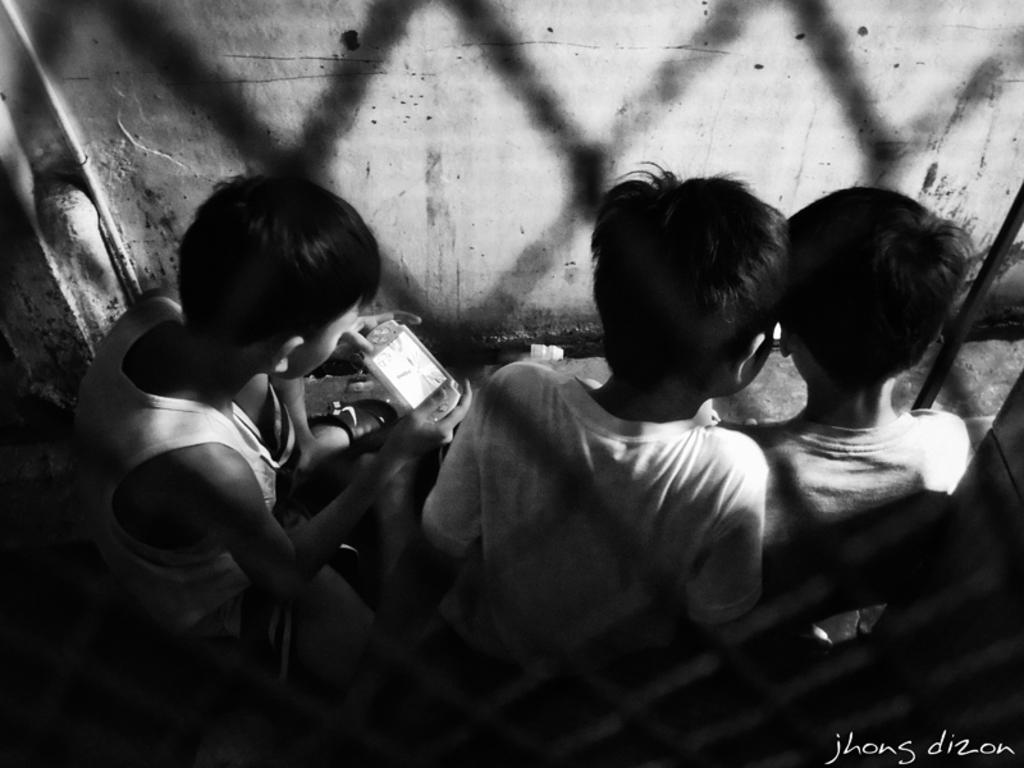How many people are wearing dresses in the image? There are three people with dresses in the image. What is one person doing with their hands in the image? One person is holding an object in the image. What can be seen in the background of the image? There is a wall in the background of the image. What is the color scheme of the image? The image is black and white. Who is the creator of the cable seen in the image? There is no cable present in the image. What type of vacation are the people in the image going on? There is no indication of a vacation in the image. 